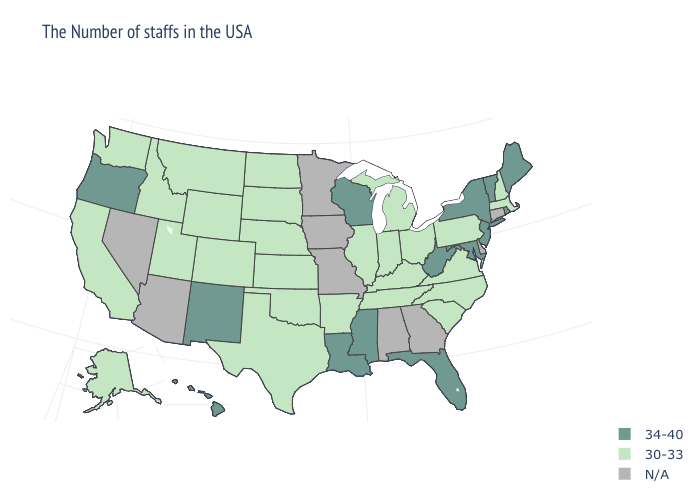Which states have the lowest value in the South?
Keep it brief. Virginia, North Carolina, South Carolina, Kentucky, Tennessee, Arkansas, Oklahoma, Texas. What is the value of New Mexico?
Short answer required. 34-40. Does Maryland have the lowest value in the South?
Keep it brief. No. Name the states that have a value in the range 30-33?
Short answer required. Massachusetts, New Hampshire, Pennsylvania, Virginia, North Carolina, South Carolina, Ohio, Michigan, Kentucky, Indiana, Tennessee, Illinois, Arkansas, Kansas, Nebraska, Oklahoma, Texas, South Dakota, North Dakota, Wyoming, Colorado, Utah, Montana, Idaho, California, Washington, Alaska. Does the first symbol in the legend represent the smallest category?
Quick response, please. No. Name the states that have a value in the range 34-40?
Answer briefly. Maine, Rhode Island, Vermont, New York, New Jersey, Maryland, West Virginia, Florida, Wisconsin, Mississippi, Louisiana, New Mexico, Oregon, Hawaii. Name the states that have a value in the range 34-40?
Short answer required. Maine, Rhode Island, Vermont, New York, New Jersey, Maryland, West Virginia, Florida, Wisconsin, Mississippi, Louisiana, New Mexico, Oregon, Hawaii. Which states have the lowest value in the USA?
Give a very brief answer. Massachusetts, New Hampshire, Pennsylvania, Virginia, North Carolina, South Carolina, Ohio, Michigan, Kentucky, Indiana, Tennessee, Illinois, Arkansas, Kansas, Nebraska, Oklahoma, Texas, South Dakota, North Dakota, Wyoming, Colorado, Utah, Montana, Idaho, California, Washington, Alaska. Name the states that have a value in the range 30-33?
Answer briefly. Massachusetts, New Hampshire, Pennsylvania, Virginia, North Carolina, South Carolina, Ohio, Michigan, Kentucky, Indiana, Tennessee, Illinois, Arkansas, Kansas, Nebraska, Oklahoma, Texas, South Dakota, North Dakota, Wyoming, Colorado, Utah, Montana, Idaho, California, Washington, Alaska. Does Maryland have the highest value in the USA?
Quick response, please. Yes. What is the value of New York?
Write a very short answer. 34-40. What is the value of South Carolina?
Keep it brief. 30-33. What is the value of Georgia?
Write a very short answer. N/A. Does Wisconsin have the lowest value in the USA?
Answer briefly. No. 